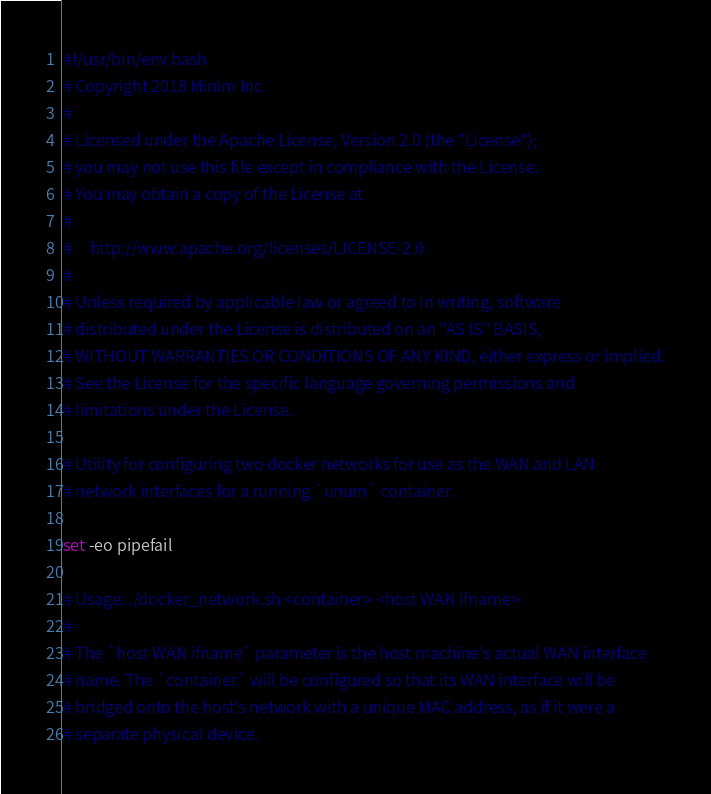<code> <loc_0><loc_0><loc_500><loc_500><_Bash_>#!/usr/bin/env bash
# Copyright 2018 Minim Inc
#
# Licensed under the Apache License, Version 2.0 (the "License");
# you may not use this file except in compliance with the License.
# You may obtain a copy of the License at
#
#     http://www.apache.org/licenses/LICENSE-2.0
#
# Unless required by applicable law or agreed to in writing, software
# distributed under the License is distributed on an "AS IS" BASIS,
# WITHOUT WARRANTIES OR CONDITIONS OF ANY KIND, either express or implied.
# See the License for the specific language governing permissions and
# limitations under the License.

# Utility for configuring two docker networks for use as the WAN and LAN
# network interfaces for a running `unum` container.

set -eo pipefail

# Usage: ./docker_network.sh <container> <host WAN ifname>
#
# The `host WAN ifname` parameter is the host machine's actual WAN interface
# name. The `container` will be configured so that its WAN interface will be
# bridged onto the host's network with a unique MAC address, as if it were a
# separate physical device.
</code> 